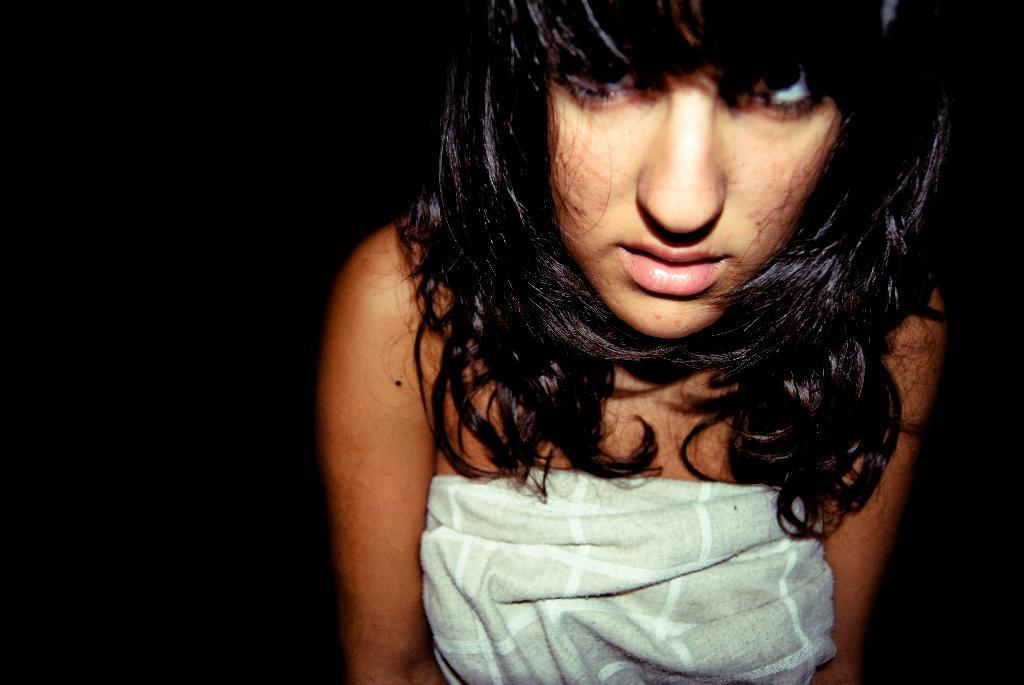Who is the main subject in the image? There is a girl in the image. What can be observed about the background of the image? The background of the image is dark. Can you tell me how many men are present in the image? There is no man present in the image; it features a girl. What type of slip can be seen on the girl's feet in the image? There is no slip visible on the girl's feet in the image. 